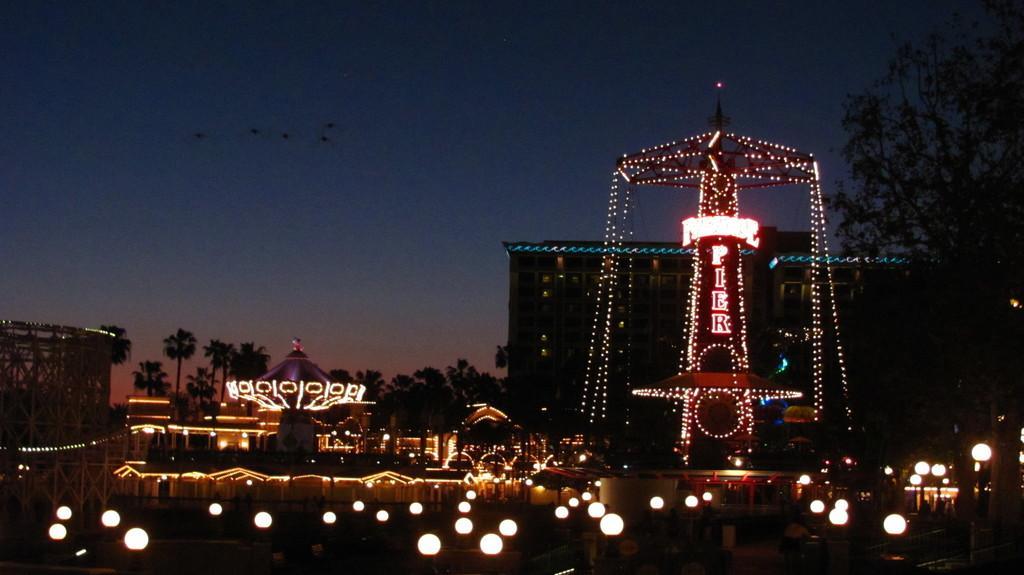In one or two sentences, can you explain what this image depicts? In the image we can see decorative lighting arrangement, here we can see the building and trees. Here we can see the lights and the sky. 